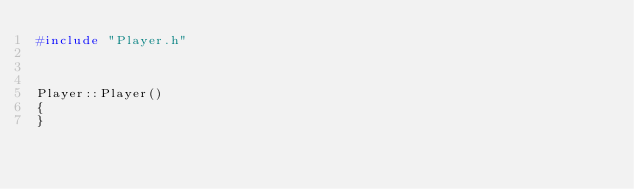<code> <loc_0><loc_0><loc_500><loc_500><_C++_>#include "Player.h"



Player::Player()
{
}


</code> 